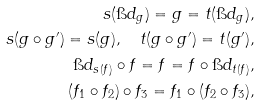Convert formula to latex. <formula><loc_0><loc_0><loc_500><loc_500>s ( \i d _ { g } ) = g = t ( \i d _ { g } ) , \\ s ( g \circ g ^ { \prime } ) = s ( g ) , \quad t ( g \circ g ^ { \prime } ) = t ( g ^ { \prime } ) , \\ \i d _ { s ( f ) } \circ f = f = f \circ \i d _ { t ( f ) } , \\ ( f _ { 1 } \circ f _ { 2 } ) \circ f _ { 3 } = f _ { 1 } \circ ( f _ { 2 } \circ f _ { 3 } ) ,</formula> 